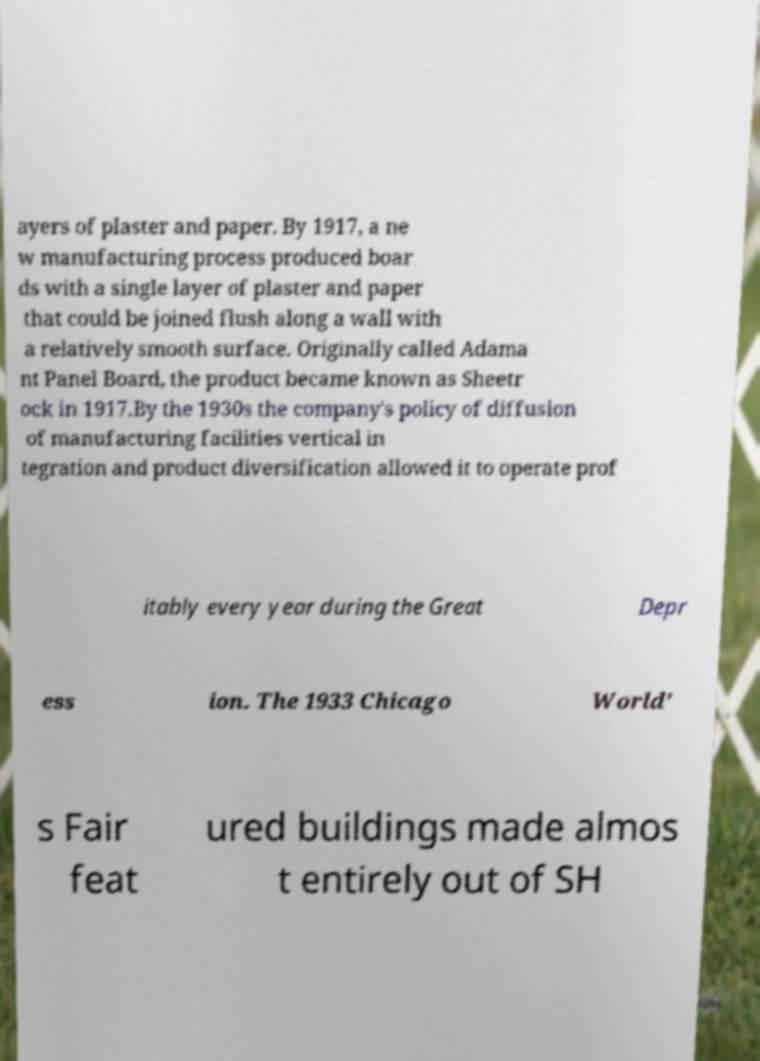Please identify and transcribe the text found in this image. ayers of plaster and paper. By 1917, a ne w manufacturing process produced boar ds with a single layer of plaster and paper that could be joined flush along a wall with a relatively smooth surface. Originally called Adama nt Panel Board, the product became known as Sheetr ock in 1917.By the 1930s the company's policy of diffusion of manufacturing facilities vertical in tegration and product diversification allowed it to operate prof itably every year during the Great Depr ess ion. The 1933 Chicago World’ s Fair feat ured buildings made almos t entirely out of SH 